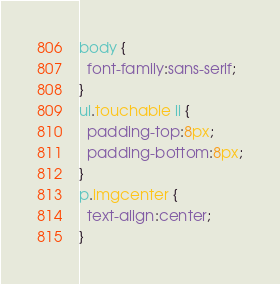<code> <loc_0><loc_0><loc_500><loc_500><_CSS_>body {
  font-family:sans-serif;
}
ul.touchable li {
  padding-top:8px;
  padding-bottom:8px;
}
p.imgcenter {
  text-align:center;
}</code> 